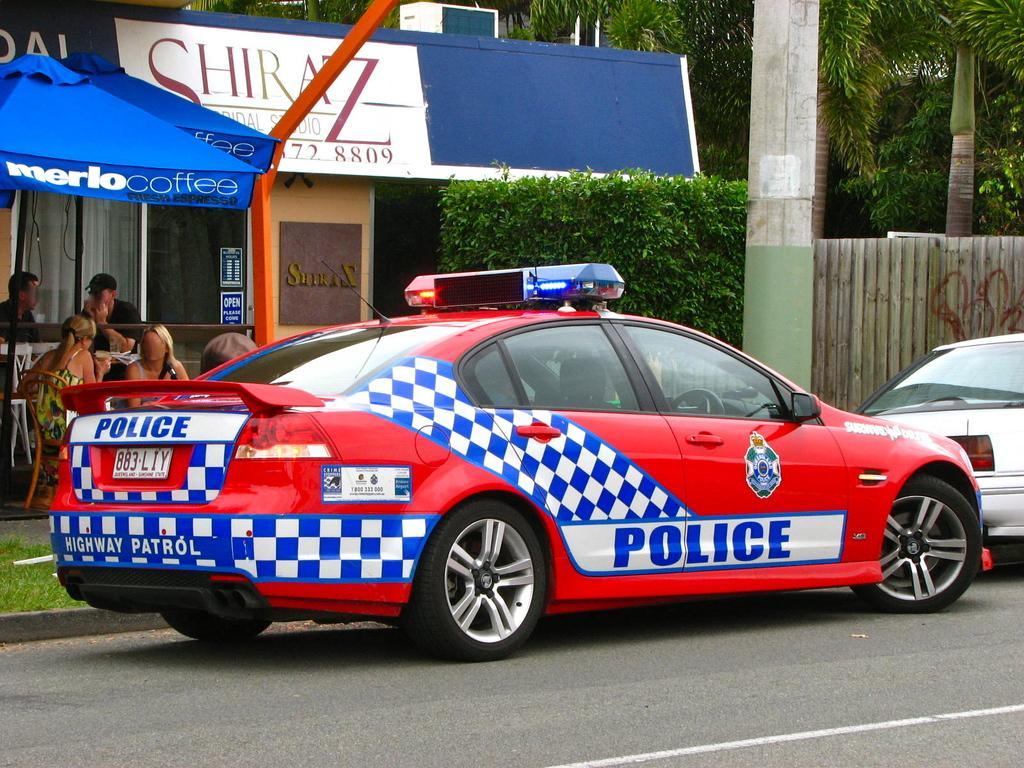In one or two sentences, can you explain what this image depicts? In this picture, we see a red car on which "POLICE" written is moving on the road. Beside that, we see people sitting on the chairs under the blue tent. Behind them, we see a coffee shop. At the top of the picture, we see a white and blue board with text written on it. On the right side, we see a wooden wall, pillar and trees. 